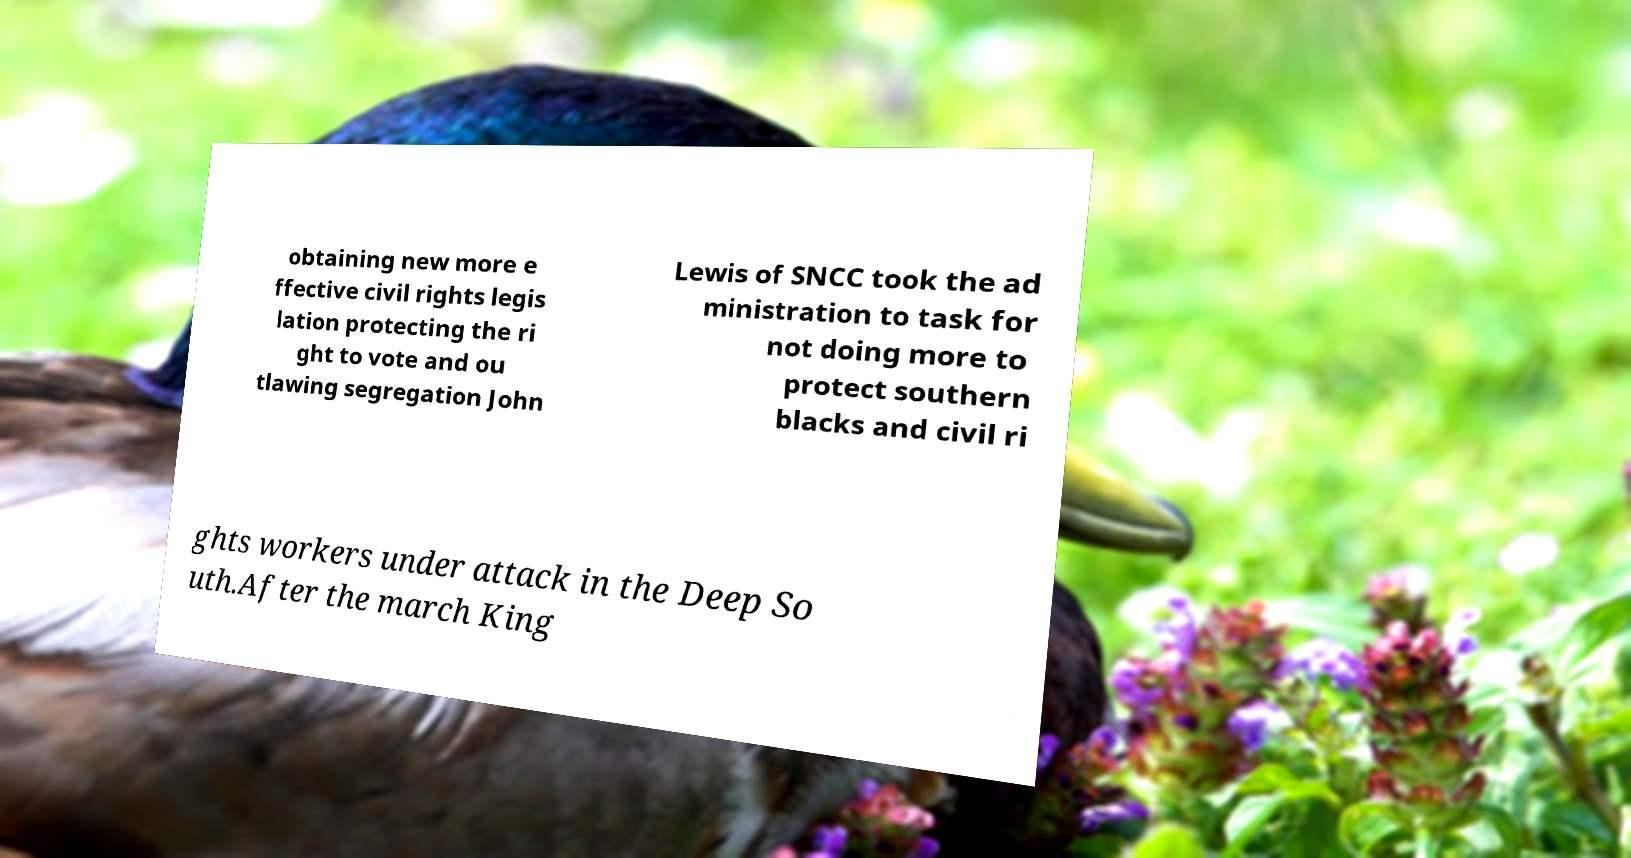I need the written content from this picture converted into text. Can you do that? obtaining new more e ffective civil rights legis lation protecting the ri ght to vote and ou tlawing segregation John Lewis of SNCC took the ad ministration to task for not doing more to protect southern blacks and civil ri ghts workers under attack in the Deep So uth.After the march King 